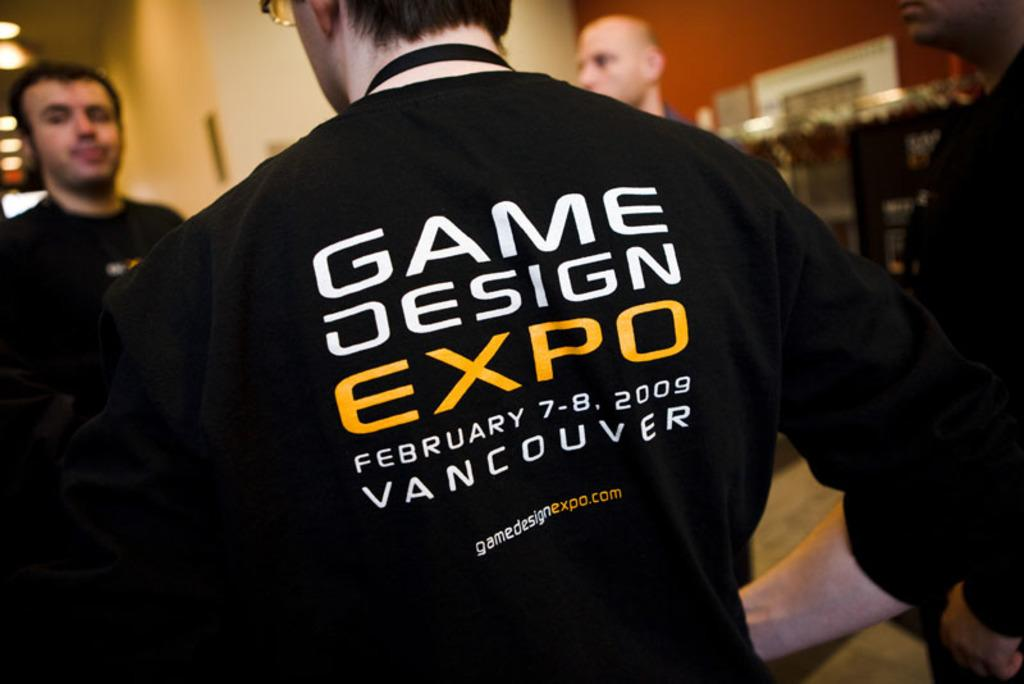<image>
Present a compact description of the photo's key features. A man wearing a black Game Design Expo shirt is standing with two other men. 